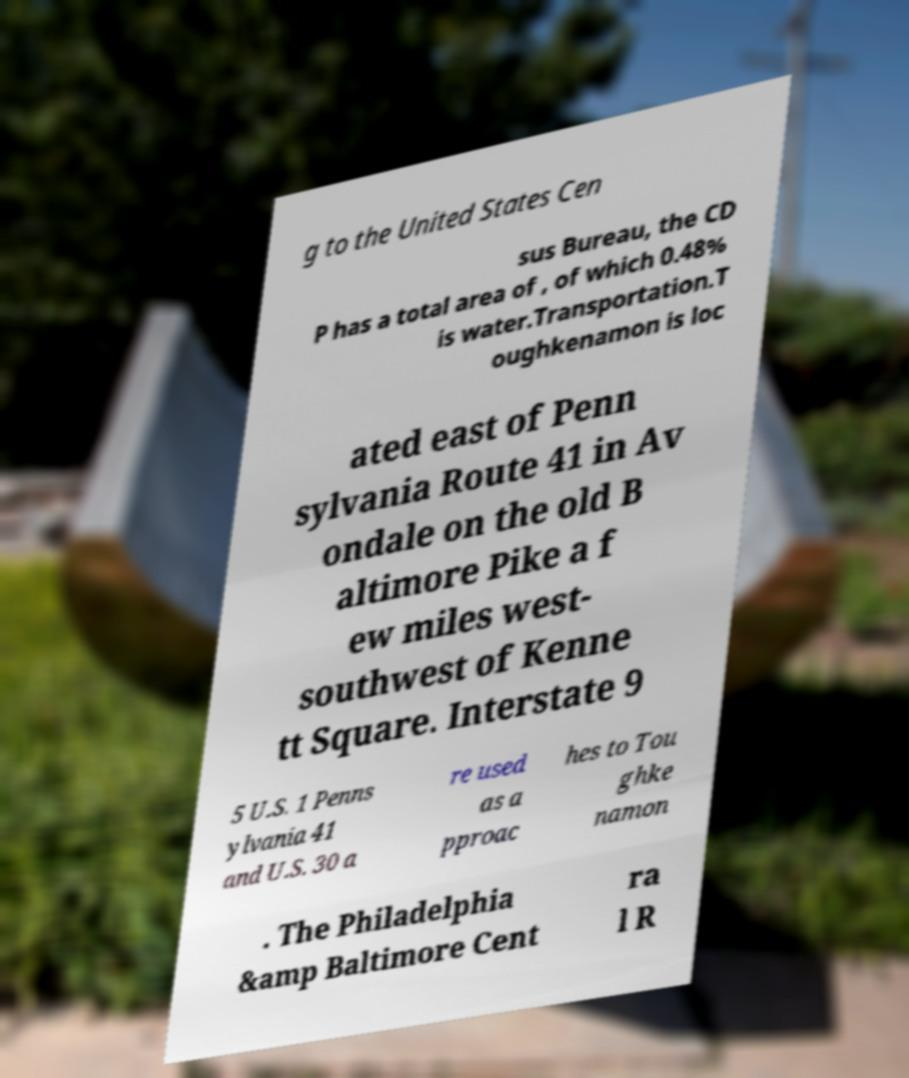There's text embedded in this image that I need extracted. Can you transcribe it verbatim? g to the United States Cen sus Bureau, the CD P has a total area of , of which 0.48% is water.Transportation.T oughkenamon is loc ated east of Penn sylvania Route 41 in Av ondale on the old B altimore Pike a f ew miles west- southwest of Kenne tt Square. Interstate 9 5 U.S. 1 Penns ylvania 41 and U.S. 30 a re used as a pproac hes to Tou ghke namon . The Philadelphia &amp Baltimore Cent ra l R 